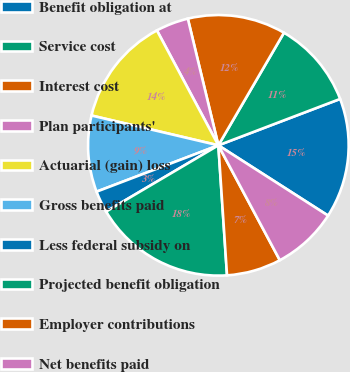Convert chart to OTSL. <chart><loc_0><loc_0><loc_500><loc_500><pie_chart><fcel>Benefit obligation at<fcel>Service cost<fcel>Interest cost<fcel>Plan participants'<fcel>Actuarial (gain) loss<fcel>Gross benefits paid<fcel>Less federal subsidy on<fcel>Projected benefit obligation<fcel>Employer contributions<fcel>Net benefits paid<nl><fcel>14.86%<fcel>10.81%<fcel>12.16%<fcel>4.05%<fcel>13.51%<fcel>9.46%<fcel>2.7%<fcel>17.57%<fcel>6.76%<fcel>8.11%<nl></chart> 